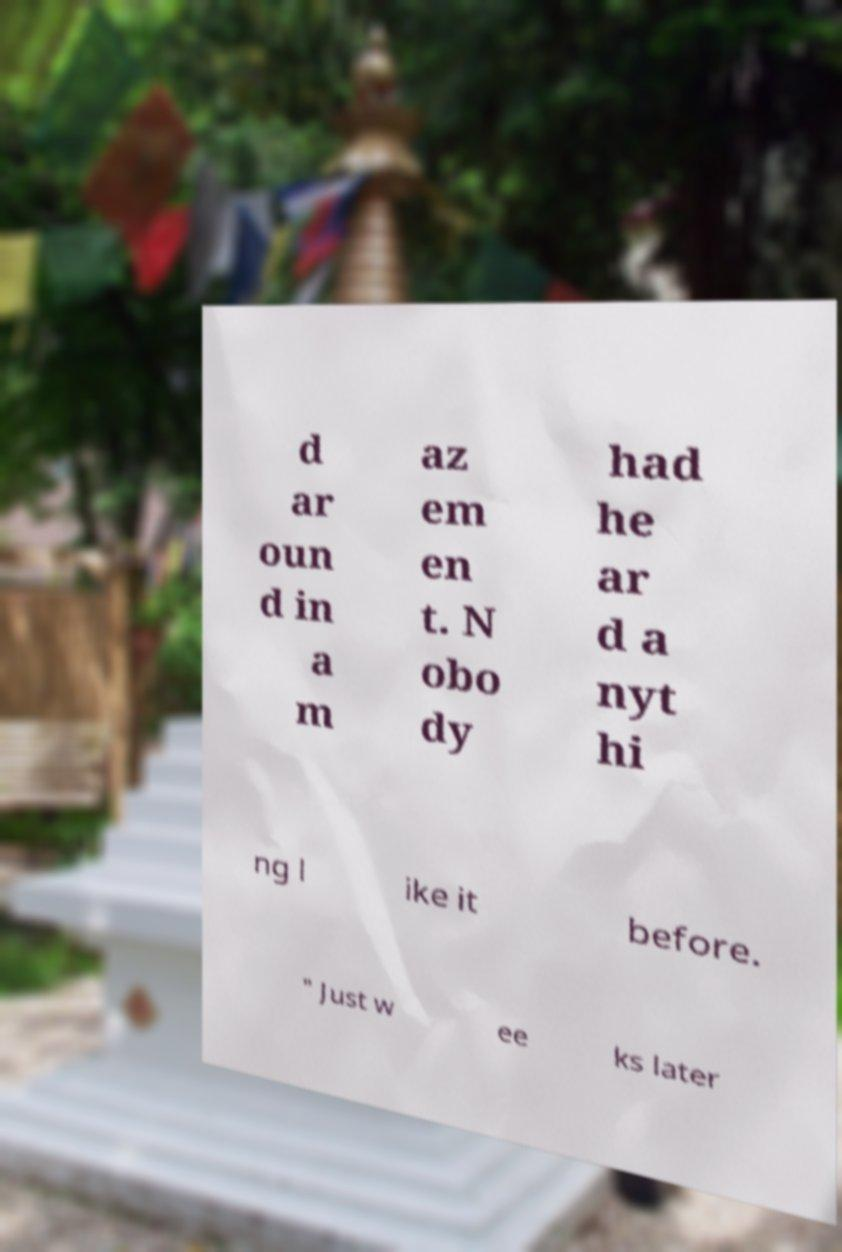I need the written content from this picture converted into text. Can you do that? d ar oun d in a m az em en t. N obo dy had he ar d a nyt hi ng l ike it before. " Just w ee ks later 